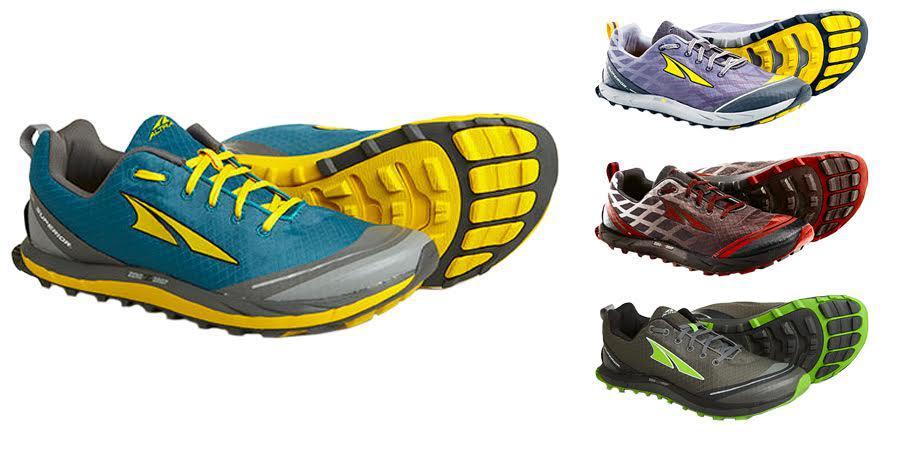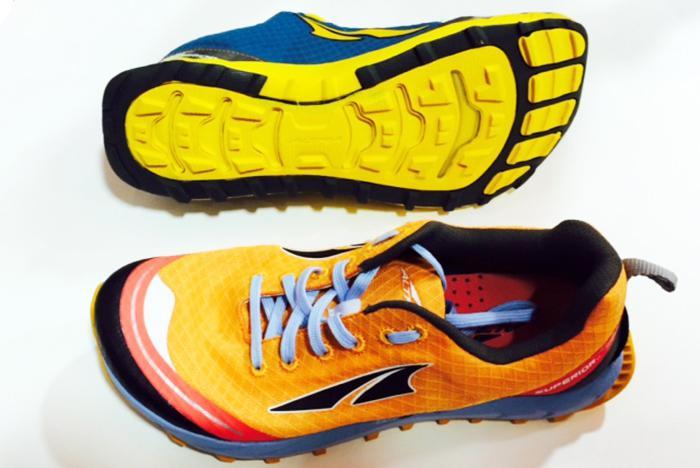The first image is the image on the left, the second image is the image on the right. For the images displayed, is the sentence "Two pairs of shoes, each laced with coordinating laces, are shown with one shoe sideways and the other shoe laying behind it with a colorful sole showing." factually correct? Answer yes or no. No. The first image is the image on the left, the second image is the image on the right. Assess this claim about the two images: "Each image contains only one pair of shoes, and each pair is displayed with one shoe in front of a shoe turned on its side.". Correct or not? Answer yes or no. No. 